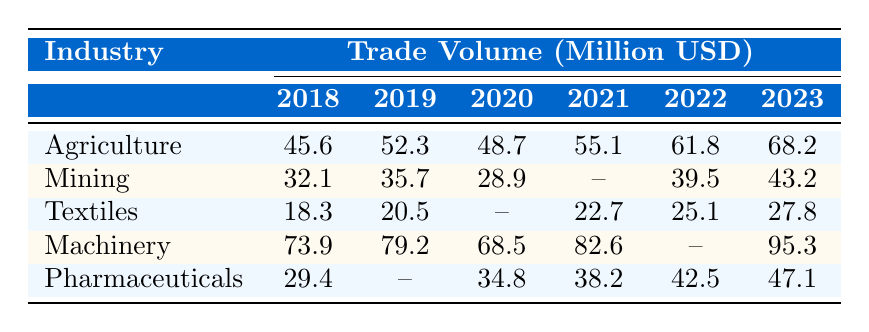What was the trade volume for the Agriculture industry in 2022? The table shows the trade volume for Agriculture in 2022 is 61.8 million USD.
Answer: 61.8 million USD Which industry had the highest trade volume in 2019? The highest trade volume in 2019 is found in the Machinery industry with 79.2 million USD.
Answer: Machinery What is the difference in trade volume for the Mining industry between 2018 and 2023? The trade volume for Mining in 2018 was 32.1 million USD and in 2023 it is 43.2 million USD, so the difference is 43.2 - 32.1 = 11.1 million USD.
Answer: 11.1 million USD What was the trade volume for the Textiles industry in 2020? The Textiles industry does not have a recorded trade volume for the year 2020, indicated by a dash in the table.
Answer: No data Calculate the average trade volume for the Machinery industry over the years 2018 to 2023. Add the trade volumes for Machinery: 73.9 + 79.2 + 68.5 + 82.6 + 95.3 = 399.5 million USD. Divide by 5 years gives 399.5 / 5 = 79.9 million USD.
Answer: 79.9 million USD Did the trade volume for Pharmaceuticals increase consistently from 2018 to 2023? In 2018, it was 29.4 million USD, then it increased to 34.8 in 2020, 38.2 in 2021, 42.5 in 2022, and 47.1 in 2023 showing a consistent increase.
Answer: Yes Which industry saw a decrease in trade volume from 2019 to 2020? Mining had a decrease from 35.7 million USD in 2019 to 28.9 million USD in 2020.
Answer: Mining What is the total trade volume for the Agriculture and Textiles industries combined in 2021? The trade volume for Agriculture in 2021 was 55.1 million USD and for Textiles it was 22.7 million USD. Their total is 55.1 + 22.7 = 77.8 million USD.
Answer: 77.8 million USD Which years saw a recorded trade volume for all five industries? The years 2018, 2019, 2021, 2022, and 2023 recorded values for Agriculture, Machinery, and Pharmaceuticals, while Mining and Textiles have missing data for some years, so only 2018, 2019, 2021 and 2022 have values for 4 industries, but 2023 has only 3.
Answer: 2018, 2019, 2021, and 2022 What is the trend of trade volume in the Agriculture industry over the years? The trade volume for Agriculture has increased each year from 45.6 million USD in 2018 to 68.2 million USD in 2023, indicating a positive trend.
Answer: Increasing trend 